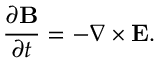<formula> <loc_0><loc_0><loc_500><loc_500>\frac { \partial { B } } { \partial t } = - \nabla \times { E } .</formula> 